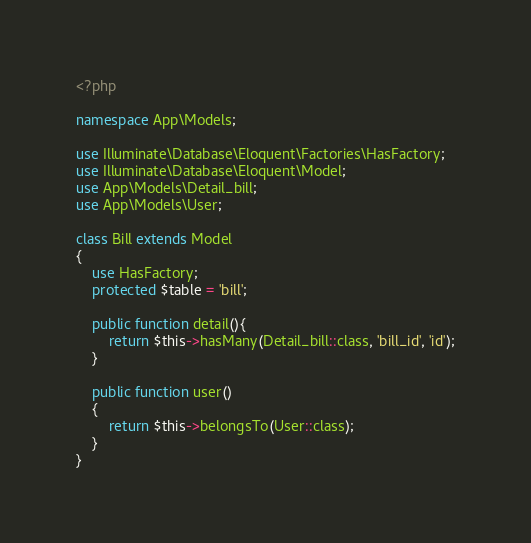Convert code to text. <code><loc_0><loc_0><loc_500><loc_500><_PHP_><?php

namespace App\Models;

use Illuminate\Database\Eloquent\Factories\HasFactory;
use Illuminate\Database\Eloquent\Model;
use App\Models\Detail_bill;
use App\Models\User;

class Bill extends Model
{
    use HasFactory;
    protected $table = 'bill';

    public function detail(){
        return $this->hasMany(Detail_bill::class, 'bill_id', 'id');
    }

    public function user()
    {
        return $this->belongsTo(User::class);
    }
}
</code> 